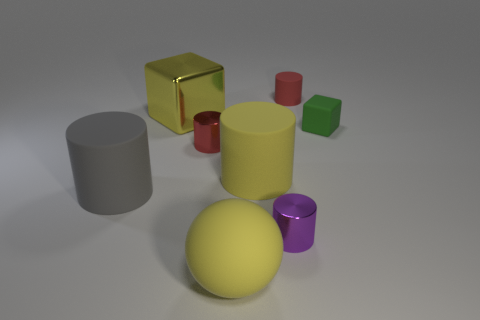What number of metal objects are either big blue blocks or green things?
Your answer should be compact. 0. There is a small cylinder that is in front of the yellow rubber cylinder; how many tiny cylinders are to the left of it?
Give a very brief answer. 1. The metal thing that is the same color as the tiny rubber cylinder is what size?
Ensure brevity in your answer.  Small. How many objects are either large yellow things or metal objects in front of the shiny cube?
Your answer should be compact. 5. Is there a green thing that has the same material as the big cube?
Your answer should be compact. No. How many large objects are both in front of the big shiny block and on the left side of the tiny red metallic cylinder?
Your response must be concise. 1. What material is the thing that is behind the yellow cube?
Make the answer very short. Rubber. There is a sphere that is the same material as the gray cylinder; what size is it?
Your answer should be compact. Large. Are there any tiny metal things behind the tiny red rubber cylinder?
Your answer should be very brief. No. What size is the purple metallic thing that is the same shape as the tiny red metallic thing?
Your answer should be very brief. Small. 